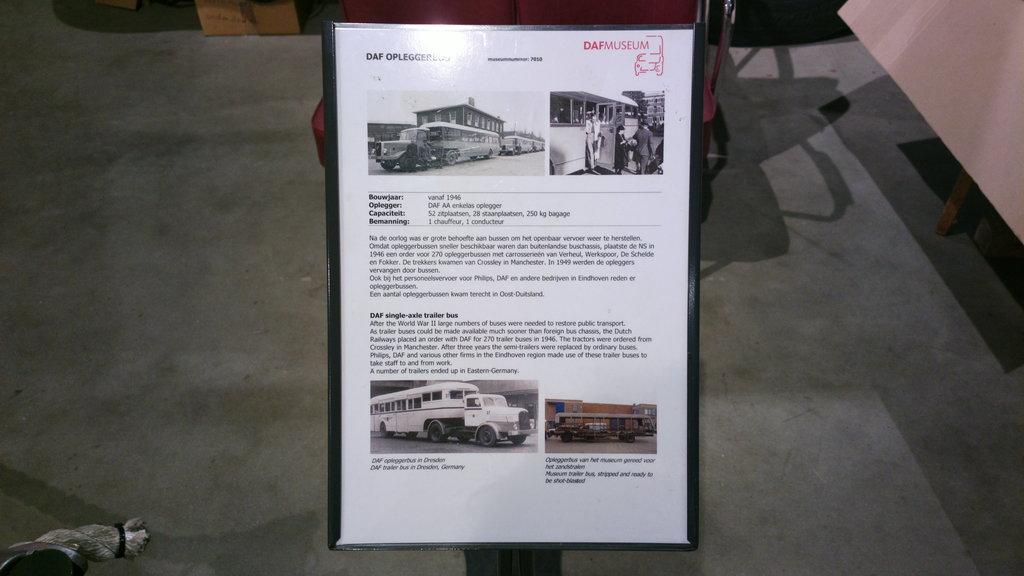Please provide a concise description of this image. There is a poster kept on a pad there is some information mentioned about the vehicles,behind the notice board there is a shadow of some object on the floor. 